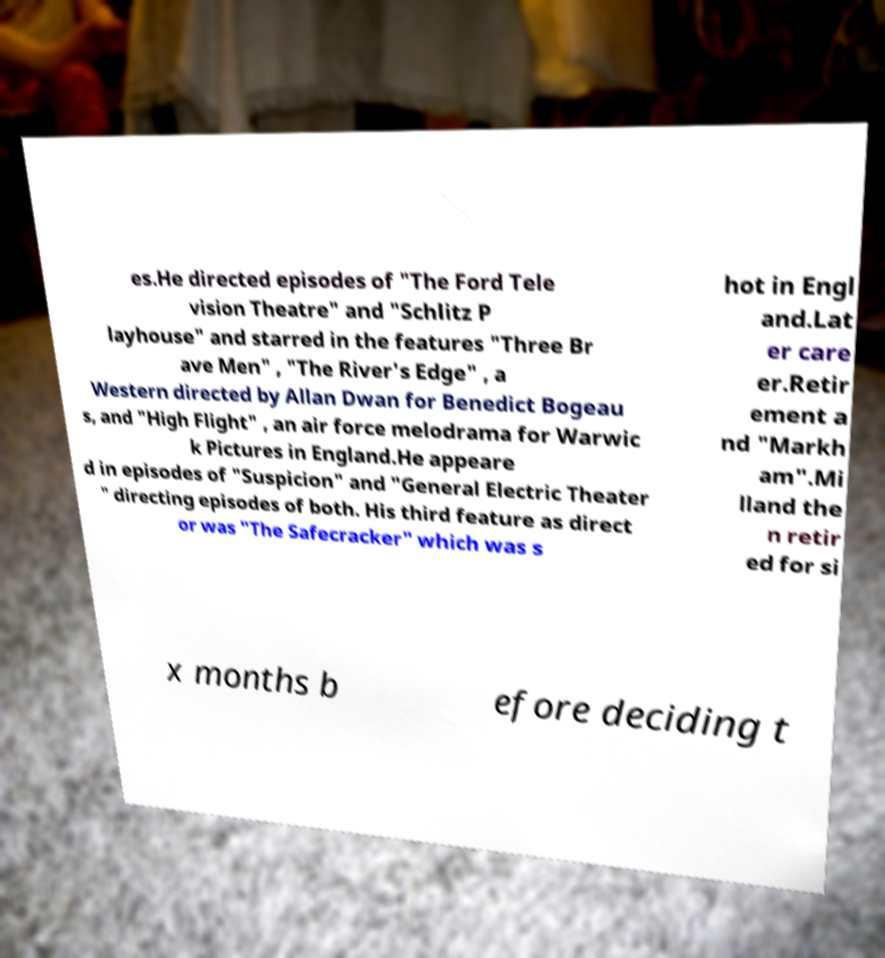What messages or text are displayed in this image? I need them in a readable, typed format. es.He directed episodes of "The Ford Tele vision Theatre" and "Schlitz P layhouse" and starred in the features "Three Br ave Men" , "The River's Edge" , a Western directed by Allan Dwan for Benedict Bogeau s, and "High Flight" , an air force melodrama for Warwic k Pictures in England.He appeare d in episodes of "Suspicion" and "General Electric Theater " directing episodes of both. His third feature as direct or was "The Safecracker" which was s hot in Engl and.Lat er care er.Retir ement a nd "Markh am".Mi lland the n retir ed for si x months b efore deciding t 